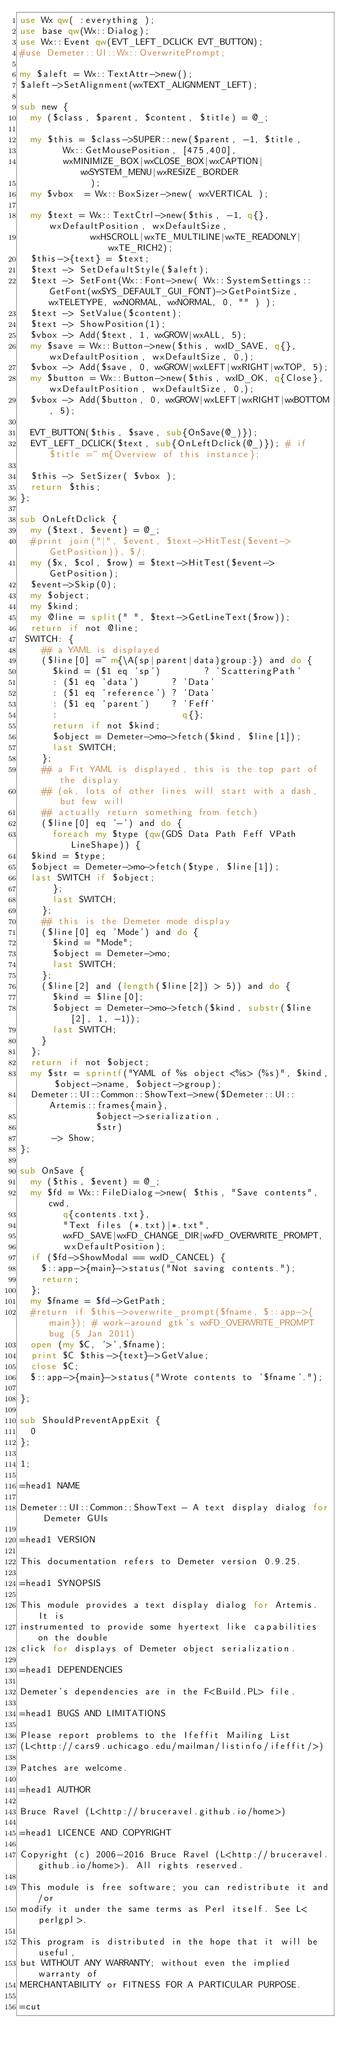Convert code to text. <code><loc_0><loc_0><loc_500><loc_500><_Perl_>use Wx qw( :everything );
use base qw(Wx::Dialog);
use Wx::Event qw(EVT_LEFT_DCLICK EVT_BUTTON);
#use Demeter::UI::Wx::OverwritePrompt;

my $aleft = Wx::TextAttr->new();
$aleft->SetAlignment(wxTEXT_ALIGNMENT_LEFT);

sub new {
  my ($class, $parent, $content, $title) = @_;

  my $this = $class->SUPER::new($parent, -1, $title,
				Wx::GetMousePosition, [475,400],
				wxMINIMIZE_BOX|wxCLOSE_BOX|wxCAPTION|wxSYSTEM_MENU|wxRESIZE_BORDER
			       );
  my $vbox  = Wx::BoxSizer->new( wxVERTICAL );

  my $text = Wx::TextCtrl->new($this, -1, q{}, wxDefaultPosition, wxDefaultSize,
			       wxHSCROLL|wxTE_MULTILINE|wxTE_READONLY|wxTE_RICH2);
  $this->{text} = $text;
  $text -> SetDefaultStyle($aleft);
  $text -> SetFont(Wx::Font->new( Wx::SystemSettings::GetFont(wxSYS_DEFAULT_GUI_FONT)->GetPointSize, wxTELETYPE, wxNORMAL, wxNORMAL, 0, "" ) );
  $text -> SetValue($content);
  $text -> ShowPosition(1);
  $vbox -> Add($text, 1, wxGROW|wxALL, 5);
  my $save = Wx::Button->new($this, wxID_SAVE, q{}, wxDefaultPosition, wxDefaultSize, 0,);
  $vbox -> Add($save, 0, wxGROW|wxLEFT|wxRIGHT|wxTOP, 5);
  my $button = Wx::Button->new($this, wxID_OK, q{Close}, wxDefaultPosition, wxDefaultSize, 0,);
  $vbox -> Add($button, 0, wxGROW|wxLEFT|wxRIGHT|wxBOTTOM, 5);

  EVT_BUTTON($this, $save, sub{OnSave(@_)});
  EVT_LEFT_DCLICK($text, sub{OnLeftDclick(@_)}); # if $title =~ m{Overview of this instance};

  $this -> SetSizer( $vbox );
  return $this;
};

sub OnLeftDclick {
  my ($text, $event) = @_;
  #print join("|", $event, $text->HitTest($event->GetPosition)), $/;
  my ($x, $col, $row) = $text->HitTest($event->GetPosition);
  $event->Skip(0);
  my $object;
  my $kind;
  my @line = split(" ", $text->GetLineText($row));
  return if not @line;
 SWITCH: {
    ## a YAML is displayed
    ($line[0] =~ m{\A(sp|parent|data)group:}) and do {
      $kind = ($1 eq 'sp')        ? 'ScatteringPath'
	    : ($1 eq 'data')      ? 'Data'
	    : ($1 eq 'reference') ? 'Data'
	    : ($1 eq 'parent')    ? 'Feff'
	    :                       q{};
      return if not $kind;
      $object = Demeter->mo->fetch($kind, $line[1]);
      last SWITCH;
    };
    ## a Fit YAML is displayed, this is the top part of the display
    ## (ok, lots of other lines will start with a dash, but few will
    ## actually return something from fetch)
    ($line[0] eq '-') and do {
      foreach my $type (qw(GDS Data Path Feff VPath LineShape)) {
	$kind = $type;
	$object = Demeter->mo->fetch($type, $line[1]);
	last SWITCH if $object;
      };
      last SWITCH;
    };
    ## this is the Demeter mode display
    ($line[0] eq 'Mode') and do {
      $kind = "Mode";
      $object = Demeter->mo;
      last SWITCH;
    };
    ($line[2] and (length($line[2]) > 5)) and do {
      $kind = $line[0];
      $object = Demeter->mo->fetch($kind, substr($line[2], 1, -1));
      last SWITCH;
    }
  };
  return if not $object;
  my $str = sprintf("YAML of %s object <%s> (%s)", $kind, $object->name, $object->group);
  Demeter::UI::Common::ShowText->new($Demeter::UI::Artemis::frames{main},
				      $object->serialization,
				      $str)
      -> Show;
};

sub OnSave {
  my ($this, $event) = @_;
  my $fd = Wx::FileDialog->new( $this, "Save contents", cwd,
				q{contents.txt},
				"Text files (*.txt)|*.txt",
				wxFD_SAVE|wxFD_CHANGE_DIR|wxFD_OVERWRITE_PROMPT,
				wxDefaultPosition);
  if ($fd->ShowModal == wxID_CANCEL) {
    $::app->{main}->status("Not saving contents.");
    return;
  };
  my $fname = $fd->GetPath;
  #return if $this->overwrite_prompt($fname, $::app->{main}); # work-around gtk's wxFD_OVERWRITE_PROMPT bug (5 Jan 2011)
  open (my $C, '>',$fname);
  print $C $this->{text}->GetValue;
  close $C;
  $::app->{main}->status("Wrote contents to '$fname'.");

};

sub ShouldPreventAppExit {
  0
};

1;

=head1 NAME

Demeter::UI::Common::ShowText - A text display dialog for Demeter GUIs

=head1 VERSION

This documentation refers to Demeter version 0.9.25.

=head1 SYNOPSIS

This module provides a text display dialog for Artemis.  It is
instrumented to provide some hyertext like capabilities on the double
click for displays of Demeter object serialization.

=head1 DEPENDENCIES

Demeter's dependencies are in the F<Build.PL> file.

=head1 BUGS AND LIMITATIONS

Please report problems to the Ifeffit Mailing List
(L<http://cars9.uchicago.edu/mailman/listinfo/ifeffit/>)

Patches are welcome.

=head1 AUTHOR

Bruce Ravel (L<http://bruceravel.github.io/home>)

=head1 LICENCE AND COPYRIGHT

Copyright (c) 2006-2016 Bruce Ravel (L<http://bruceravel.github.io/home>). All rights reserved.

This module is free software; you can redistribute it and/or
modify it under the same terms as Perl itself. See L<perlgpl>.

This program is distributed in the hope that it will be useful,
but WITHOUT ANY WARRANTY; without even the implied warranty of
MERCHANTABILITY or FITNESS FOR A PARTICULAR PURPOSE.

=cut
</code> 